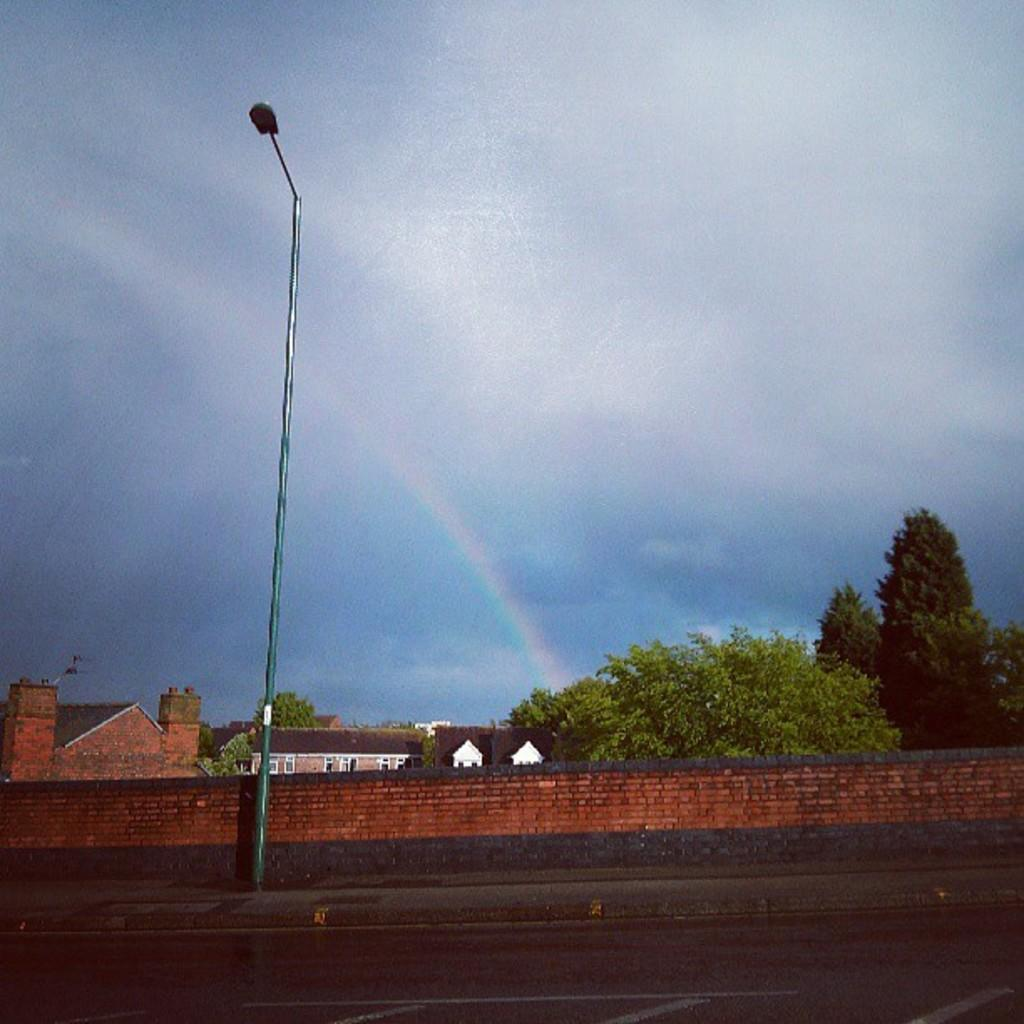What color is the sky in the image? The sky is blue in the image. What structure can be seen in the image? There is a light pole in the image. What type of vegetation is visible behind the wall? Trees are visible behind the wall. What type of buildings are present in the image? There are houses with windows in the image. What type of animal can be seen interacting with the light pole in the image? There are no animals present in the image, and the light pole is not being interacted with. 